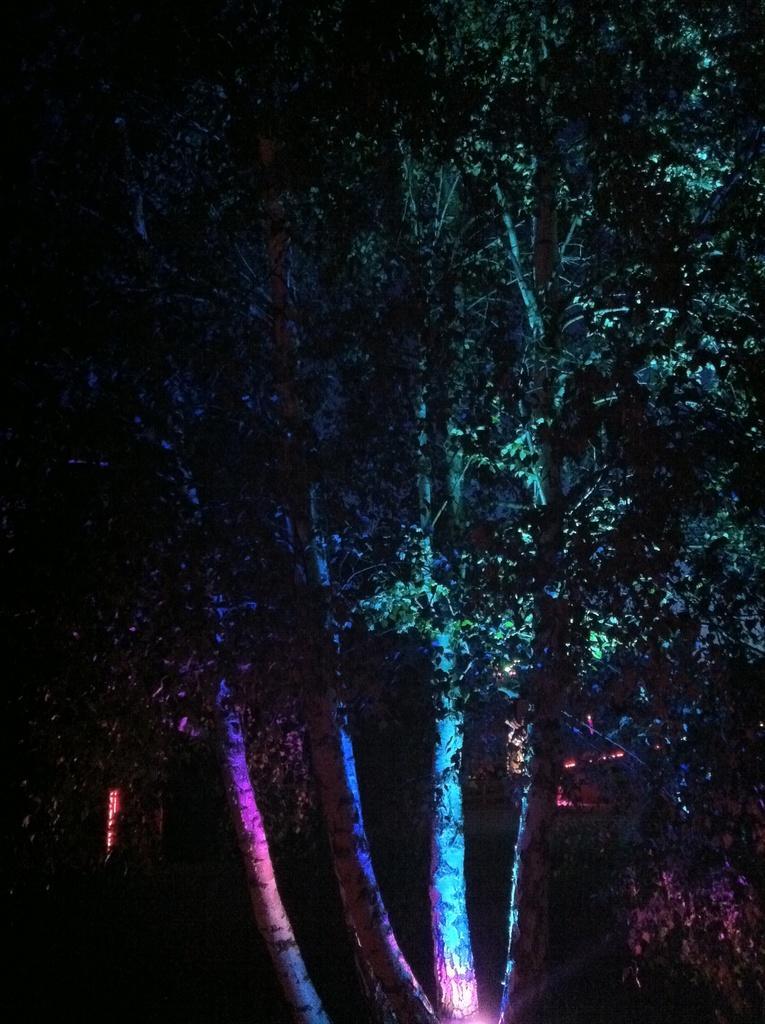In one or two sentences, can you explain what this image depicts? In this image I can see a tree and I can see this image is little bit in dark. 